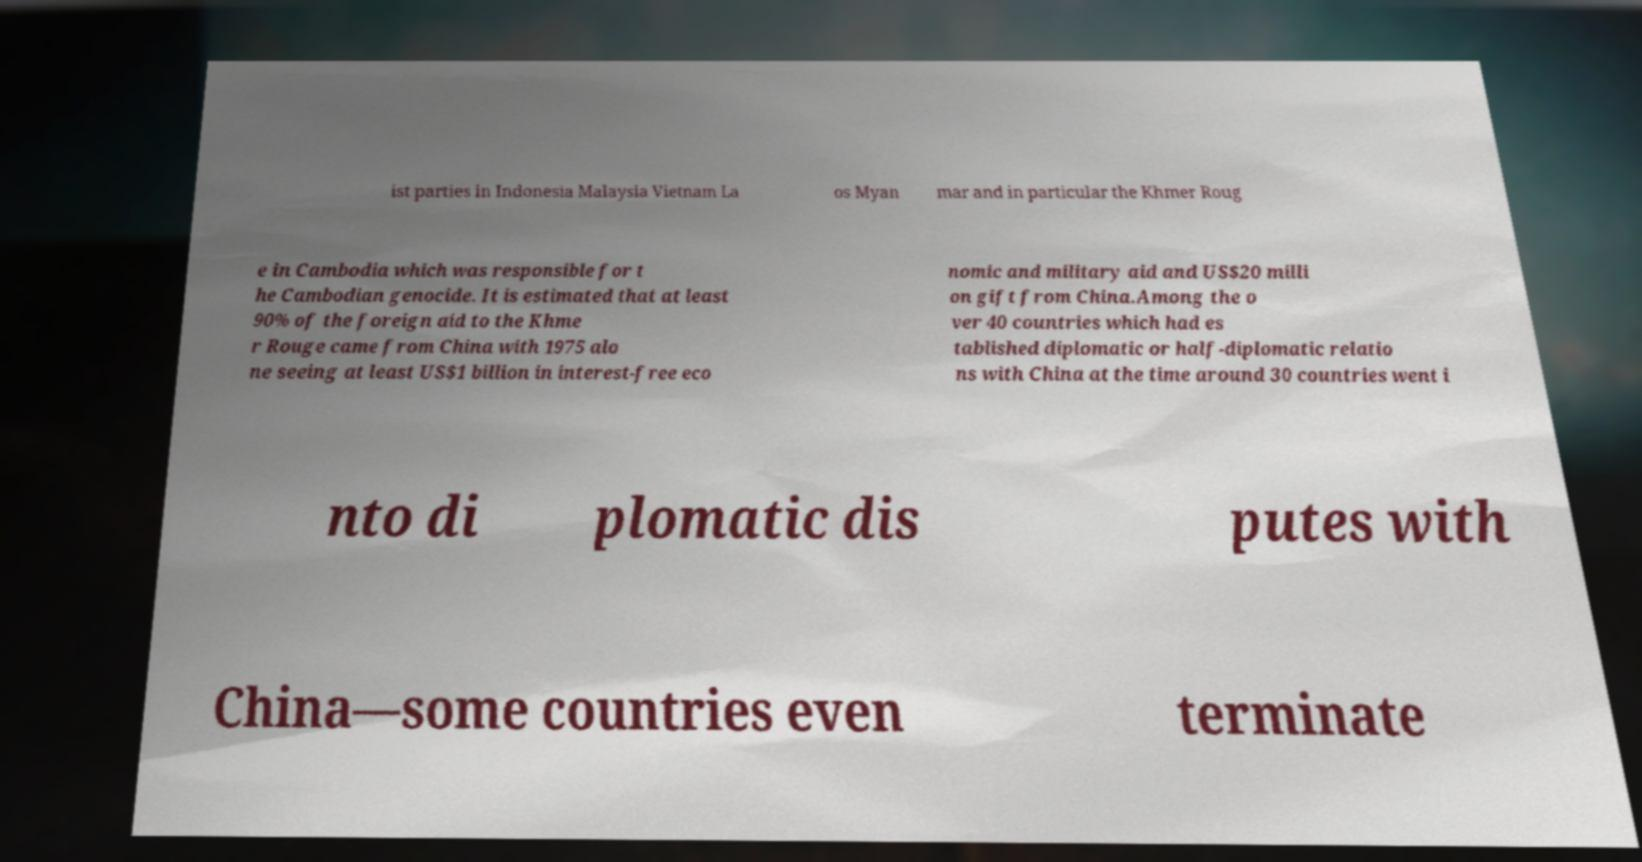What messages or text are displayed in this image? I need them in a readable, typed format. ist parties in Indonesia Malaysia Vietnam La os Myan mar and in particular the Khmer Roug e in Cambodia which was responsible for t he Cambodian genocide. It is estimated that at least 90% of the foreign aid to the Khme r Rouge came from China with 1975 alo ne seeing at least US$1 billion in interest-free eco nomic and military aid and US$20 milli on gift from China.Among the o ver 40 countries which had es tablished diplomatic or half-diplomatic relatio ns with China at the time around 30 countries went i nto di plomatic dis putes with China—some countries even terminate 